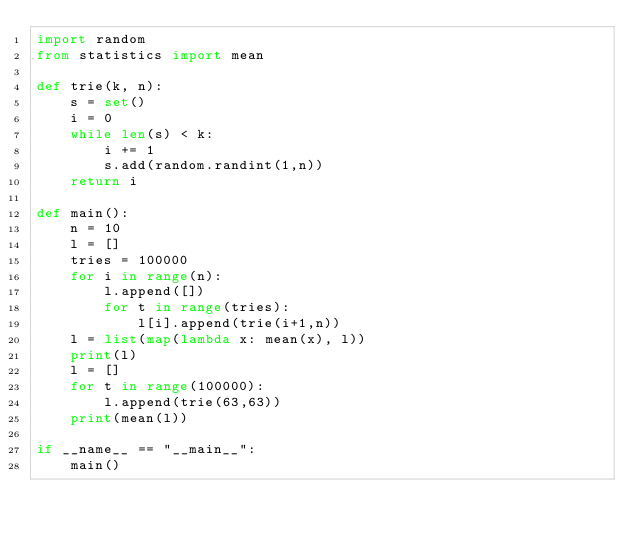<code> <loc_0><loc_0><loc_500><loc_500><_Python_>import random
from statistics import mean

def trie(k, n):
    s = set()
    i = 0
    while len(s) < k:
        i += 1
        s.add(random.randint(1,n))
    return i

def main():
    n = 10
    l = []
    tries = 100000
    for i in range(n):
        l.append([])
        for t in range(tries):
            l[i].append(trie(i+1,n))
    l = list(map(lambda x: mean(x), l))
    print(l)
    l = []
    for t in range(100000):
        l.append(trie(63,63))
    print(mean(l))

if __name__ == "__main__":
    main()
</code> 